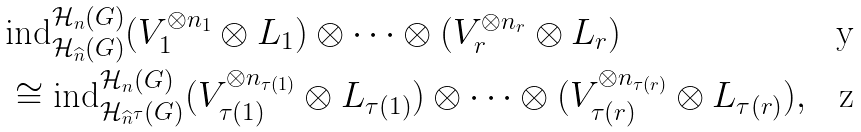Convert formula to latex. <formula><loc_0><loc_0><loc_500><loc_500>& \text {ind} _ { \mathcal { H } _ { \widehat { n } } ( G ) } ^ { \mathcal { H } _ { n } ( G ) } ( V _ { 1 } ^ { \otimes n _ { 1 } } \otimes L _ { 1 } ) \otimes \cdots \otimes ( V _ { r } ^ { \otimes n _ { r } } \otimes L _ { r } ) \\ & \cong \text {ind} _ { \mathcal { H } _ { \widehat { n } ^ { \tau } } ( G ) } ^ { \mathcal { H } _ { n } ( G ) } ( V _ { \tau ( 1 ) } ^ { \otimes n _ { \tau ( 1 ) } } \otimes L _ { \tau ( 1 ) } ) \otimes \cdots \otimes ( V _ { \tau ( r ) } ^ { \otimes n _ { \tau ( r ) } } \otimes L _ { \tau ( r ) } ) ,</formula> 